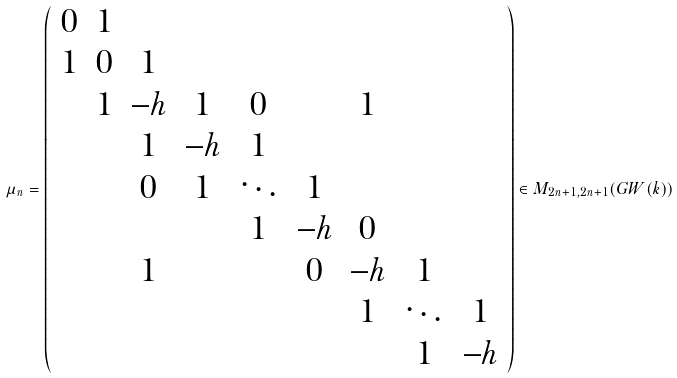Convert formula to latex. <formula><loc_0><loc_0><loc_500><loc_500>\mu _ { n } = \left ( \begin{array} { c c c c c c c c c } 0 & 1 \\ 1 & 0 & 1 \\ & 1 & - h & 1 & 0 & & 1 \\ & & 1 & - h & 1 \\ & & 0 & 1 & \ddots & 1 \\ & & & & 1 & - h & 0 \\ & & 1 & & & 0 & - h & 1 \\ & & & & & & 1 & \ddots & 1 \\ & & & & & & & 1 & - h \end{array} \right ) \in M _ { 2 n + 1 , 2 n + 1 } ( G W ( k ) )</formula> 